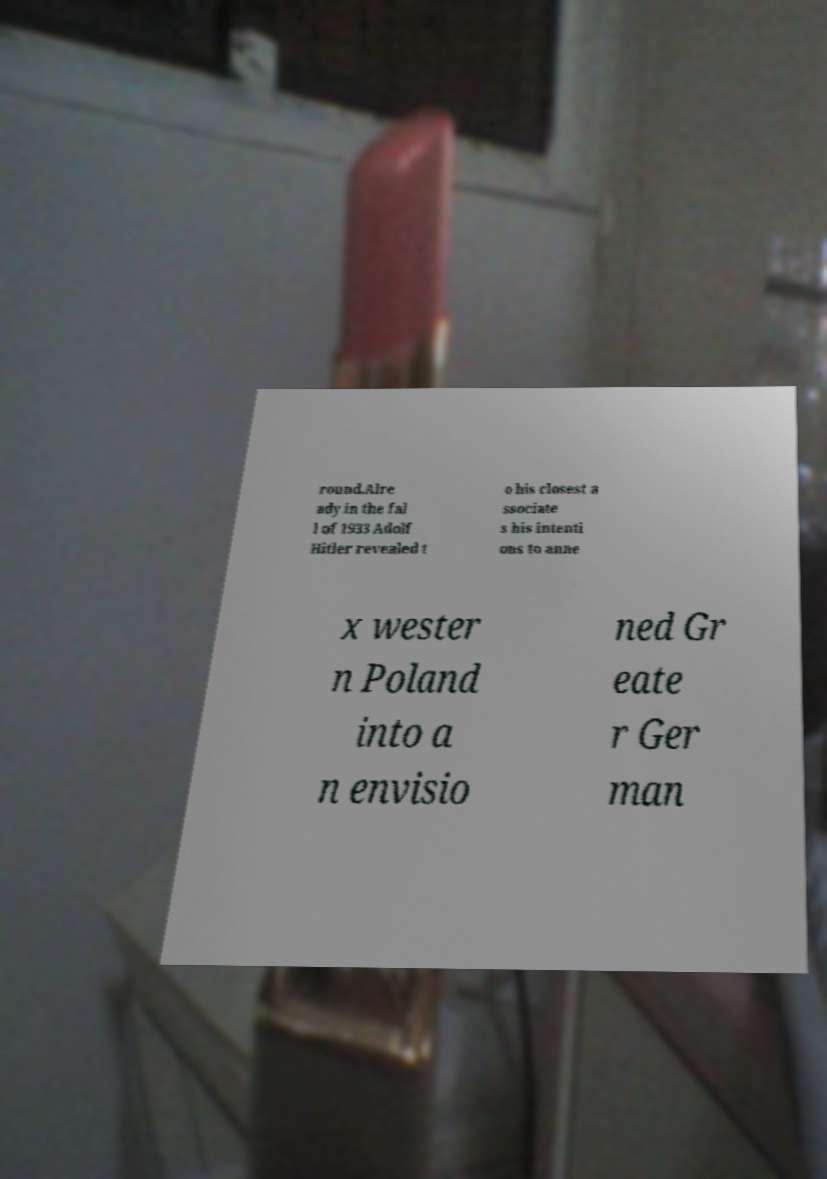Could you extract and type out the text from this image? round.Alre ady in the fal l of 1933 Adolf Hitler revealed t o his closest a ssociate s his intenti ons to anne x wester n Poland into a n envisio ned Gr eate r Ger man 